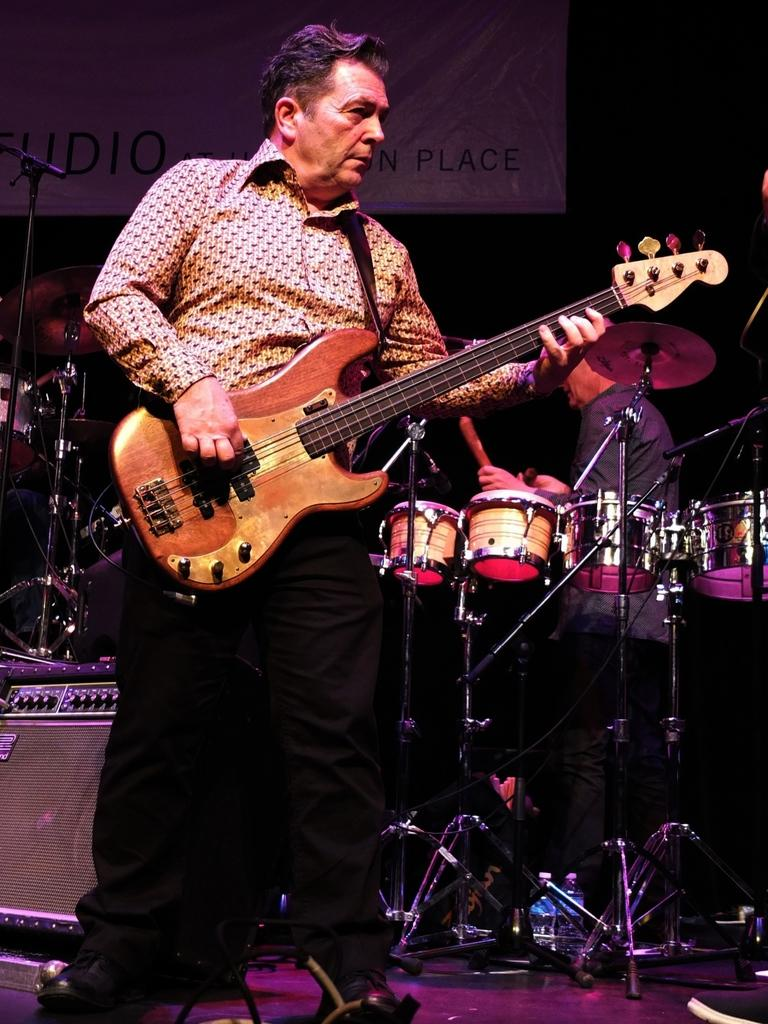What is the man in the foreground of the image holding? The man in the foreground of the image is holding a guitar. What can be seen in the background of the image? There is a man standing in front of a drum set in the background of the image. What is the purpose of the object visible near the man in the foreground? The purpose of the microphone (mic) visible in the image is likely for amplifying sound during a performance. What type of bread is being used to play volleyball in the image? There is no bread or volleyball present in the image. What type of bat is visible in the image? There is no bat present in the image. 